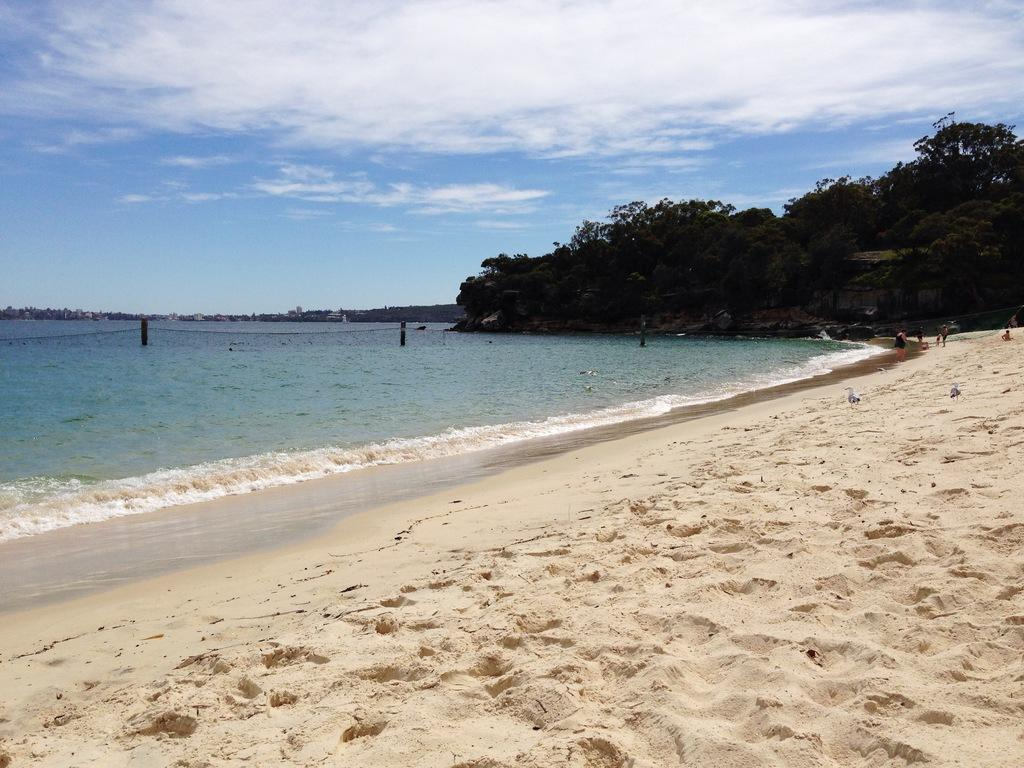What type of terrain is visible in the image? There is sand in the image, which suggests a beach or desert setting. What natural element is also present in the image? There is water in the image. What type of vegetation can be seen in the image? There are trees in the image. What is the color of the sky in the background of the image? The sky is blue in the background of the image. What can be seen in the sky in the background of the image? There are clouds visible in the sky in the background of the image. What type of bread can be seen being eaten by a monkey in the image? There is no bread or monkey present in the image. Is there a hill visible in the image? There is no hill visible in the image. 